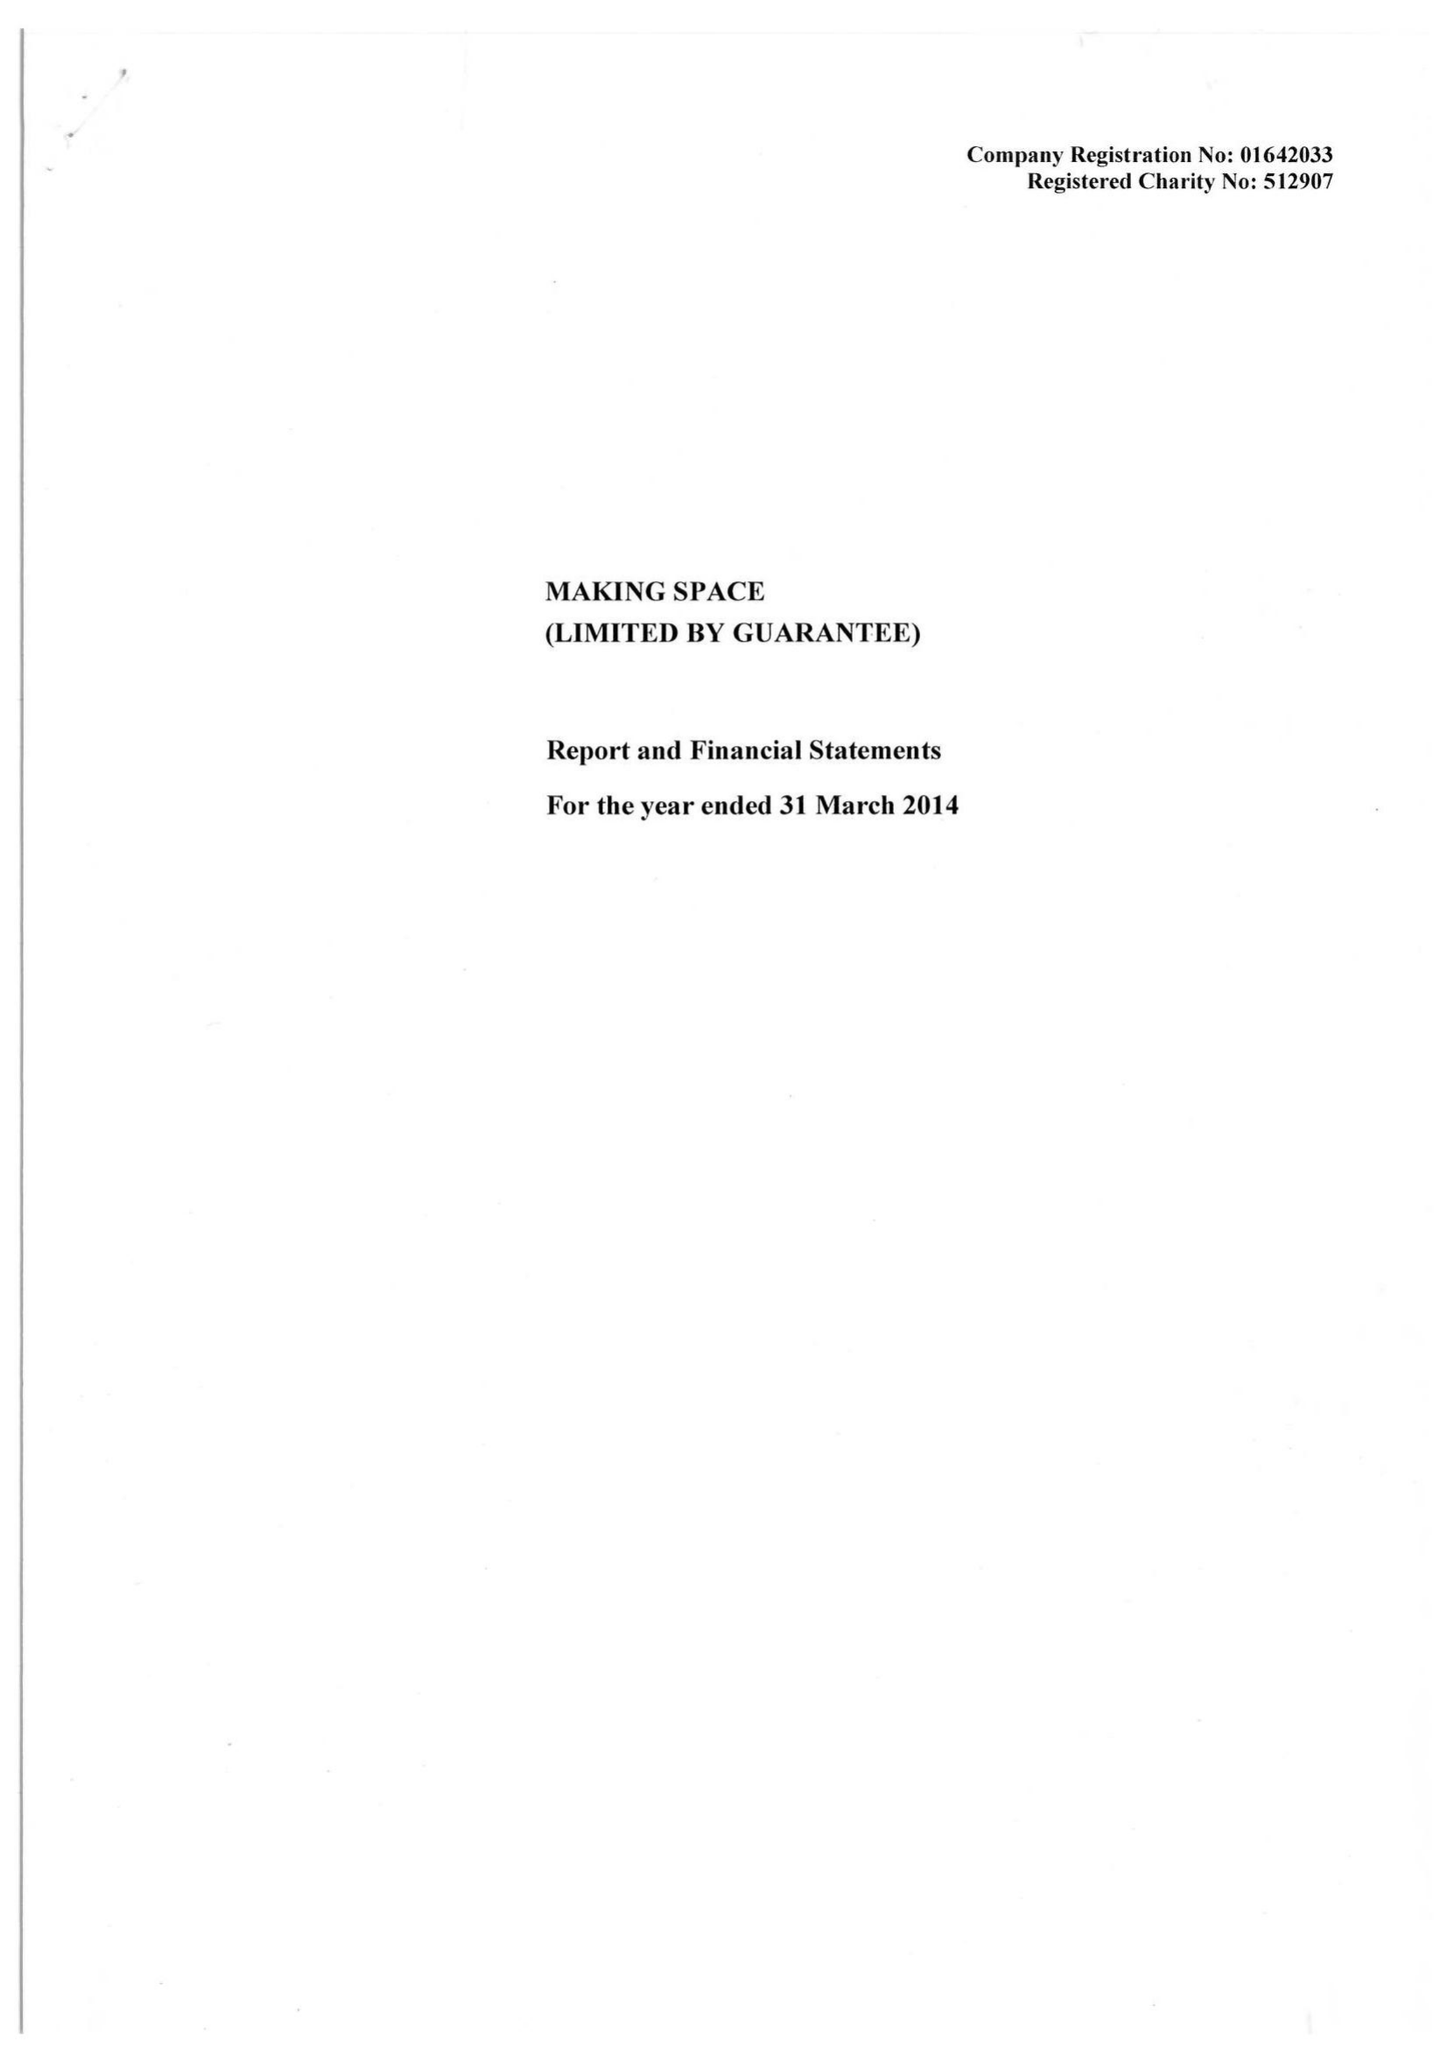What is the value for the report_date?
Answer the question using a single word or phrase. 2014-03-31 